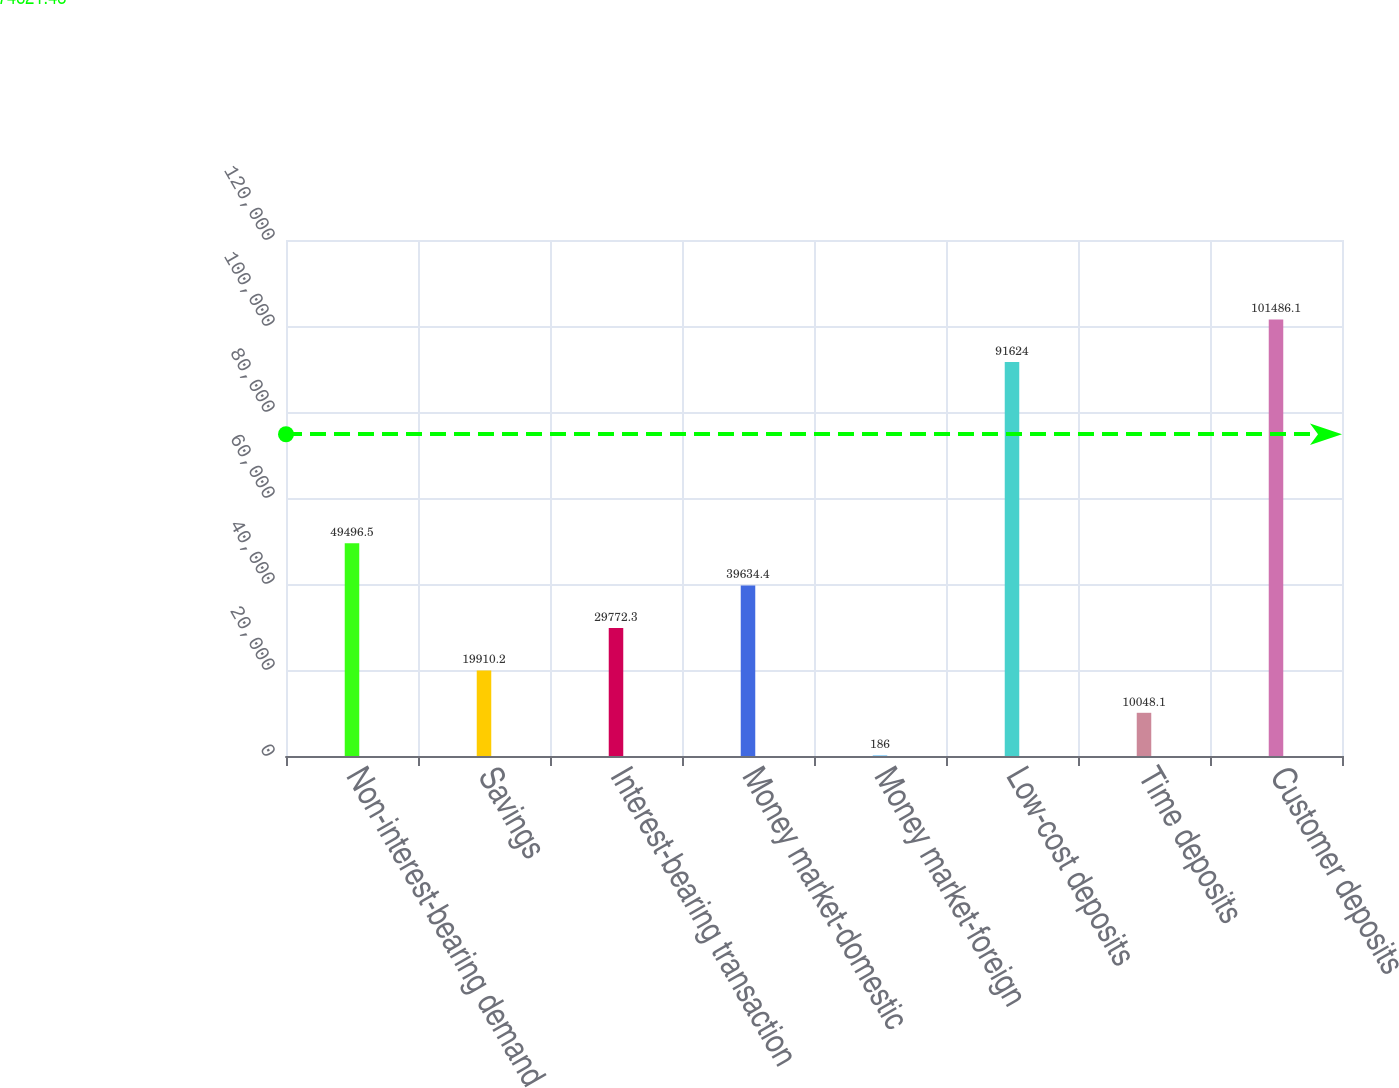<chart> <loc_0><loc_0><loc_500><loc_500><bar_chart><fcel>Non-interest-bearing demand<fcel>Savings<fcel>Interest-bearing transaction<fcel>Money market-domestic<fcel>Money market-foreign<fcel>Low-cost deposits<fcel>Time deposits<fcel>Customer deposits<nl><fcel>49496.5<fcel>19910.2<fcel>29772.3<fcel>39634.4<fcel>186<fcel>91624<fcel>10048.1<fcel>101486<nl></chart> 